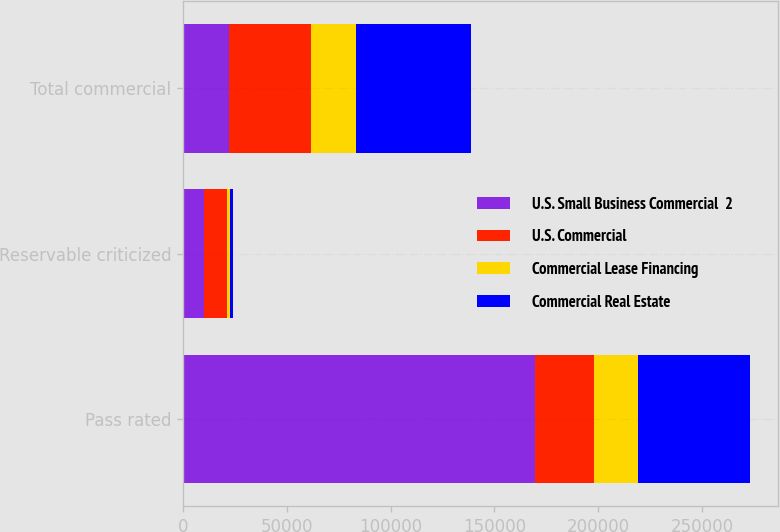Convert chart to OTSL. <chart><loc_0><loc_0><loc_500><loc_500><stacked_bar_chart><ecel><fcel>Pass rated<fcel>Reservable criticized<fcel>Total commercial<nl><fcel>U.S. Small Business Commercial  2<fcel>169599<fcel>10349<fcel>21989<nl><fcel>U.S. Commercial<fcel>28602<fcel>10994<fcel>39596<nl><fcel>Commercial Lease Financing<fcel>20850<fcel>1139<fcel>21989<nl><fcel>Commercial Real Estate<fcel>53945<fcel>1473<fcel>55418<nl></chart> 